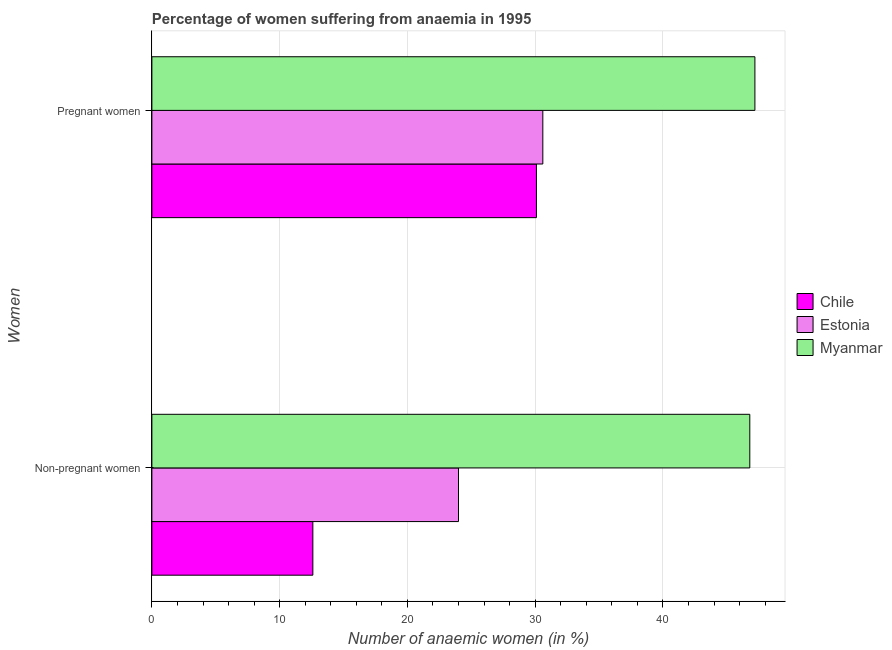How many different coloured bars are there?
Ensure brevity in your answer.  3. Are the number of bars on each tick of the Y-axis equal?
Your response must be concise. Yes. How many bars are there on the 1st tick from the bottom?
Offer a terse response. 3. What is the label of the 2nd group of bars from the top?
Make the answer very short. Non-pregnant women. Across all countries, what is the maximum percentage of non-pregnant anaemic women?
Your answer should be very brief. 46.8. Across all countries, what is the minimum percentage of pregnant anaemic women?
Give a very brief answer. 30.1. In which country was the percentage of non-pregnant anaemic women maximum?
Your answer should be compact. Myanmar. What is the total percentage of non-pregnant anaemic women in the graph?
Provide a succinct answer. 83.4. What is the difference between the percentage of non-pregnant anaemic women in Chile and that in Myanmar?
Offer a very short reply. -34.2. What is the difference between the percentage of non-pregnant anaemic women in Estonia and the percentage of pregnant anaemic women in Myanmar?
Your answer should be compact. -23.2. What is the average percentage of pregnant anaemic women per country?
Offer a very short reply. 35.97. What is the difference between the percentage of pregnant anaemic women and percentage of non-pregnant anaemic women in Estonia?
Your answer should be compact. 6.6. In how many countries, is the percentage of non-pregnant anaemic women greater than 8 %?
Make the answer very short. 3. What is the ratio of the percentage of pregnant anaemic women in Myanmar to that in Estonia?
Offer a very short reply. 1.54. In how many countries, is the percentage of pregnant anaemic women greater than the average percentage of pregnant anaemic women taken over all countries?
Offer a very short reply. 1. What does the 2nd bar from the top in Non-pregnant women represents?
Your answer should be very brief. Estonia. What does the 2nd bar from the bottom in Pregnant women represents?
Give a very brief answer. Estonia. How many bars are there?
Your response must be concise. 6. How many countries are there in the graph?
Provide a short and direct response. 3. Where does the legend appear in the graph?
Offer a very short reply. Center right. What is the title of the graph?
Offer a very short reply. Percentage of women suffering from anaemia in 1995. Does "Costa Rica" appear as one of the legend labels in the graph?
Your response must be concise. No. What is the label or title of the X-axis?
Offer a very short reply. Number of anaemic women (in %). What is the label or title of the Y-axis?
Provide a short and direct response. Women. What is the Number of anaemic women (in %) in Myanmar in Non-pregnant women?
Your response must be concise. 46.8. What is the Number of anaemic women (in %) of Chile in Pregnant women?
Make the answer very short. 30.1. What is the Number of anaemic women (in %) in Estonia in Pregnant women?
Your answer should be compact. 30.6. What is the Number of anaemic women (in %) in Myanmar in Pregnant women?
Make the answer very short. 47.2. Across all Women, what is the maximum Number of anaemic women (in %) of Chile?
Provide a succinct answer. 30.1. Across all Women, what is the maximum Number of anaemic women (in %) of Estonia?
Your answer should be compact. 30.6. Across all Women, what is the maximum Number of anaemic women (in %) of Myanmar?
Offer a terse response. 47.2. Across all Women, what is the minimum Number of anaemic women (in %) in Estonia?
Offer a terse response. 24. Across all Women, what is the minimum Number of anaemic women (in %) in Myanmar?
Keep it short and to the point. 46.8. What is the total Number of anaemic women (in %) in Chile in the graph?
Ensure brevity in your answer.  42.7. What is the total Number of anaemic women (in %) in Estonia in the graph?
Make the answer very short. 54.6. What is the total Number of anaemic women (in %) in Myanmar in the graph?
Keep it short and to the point. 94. What is the difference between the Number of anaemic women (in %) of Chile in Non-pregnant women and that in Pregnant women?
Your response must be concise. -17.5. What is the difference between the Number of anaemic women (in %) of Myanmar in Non-pregnant women and that in Pregnant women?
Your answer should be compact. -0.4. What is the difference between the Number of anaemic women (in %) of Chile in Non-pregnant women and the Number of anaemic women (in %) of Estonia in Pregnant women?
Offer a terse response. -18. What is the difference between the Number of anaemic women (in %) of Chile in Non-pregnant women and the Number of anaemic women (in %) of Myanmar in Pregnant women?
Ensure brevity in your answer.  -34.6. What is the difference between the Number of anaemic women (in %) of Estonia in Non-pregnant women and the Number of anaemic women (in %) of Myanmar in Pregnant women?
Make the answer very short. -23.2. What is the average Number of anaemic women (in %) of Chile per Women?
Offer a terse response. 21.35. What is the average Number of anaemic women (in %) in Estonia per Women?
Provide a succinct answer. 27.3. What is the difference between the Number of anaemic women (in %) of Chile and Number of anaemic women (in %) of Estonia in Non-pregnant women?
Your answer should be compact. -11.4. What is the difference between the Number of anaemic women (in %) in Chile and Number of anaemic women (in %) in Myanmar in Non-pregnant women?
Provide a short and direct response. -34.2. What is the difference between the Number of anaemic women (in %) in Estonia and Number of anaemic women (in %) in Myanmar in Non-pregnant women?
Ensure brevity in your answer.  -22.8. What is the difference between the Number of anaemic women (in %) in Chile and Number of anaemic women (in %) in Estonia in Pregnant women?
Provide a short and direct response. -0.5. What is the difference between the Number of anaemic women (in %) in Chile and Number of anaemic women (in %) in Myanmar in Pregnant women?
Provide a short and direct response. -17.1. What is the difference between the Number of anaemic women (in %) of Estonia and Number of anaemic women (in %) of Myanmar in Pregnant women?
Keep it short and to the point. -16.6. What is the ratio of the Number of anaemic women (in %) in Chile in Non-pregnant women to that in Pregnant women?
Provide a short and direct response. 0.42. What is the ratio of the Number of anaemic women (in %) in Estonia in Non-pregnant women to that in Pregnant women?
Make the answer very short. 0.78. What is the ratio of the Number of anaemic women (in %) in Myanmar in Non-pregnant women to that in Pregnant women?
Offer a very short reply. 0.99. What is the difference between the highest and the second highest Number of anaemic women (in %) of Estonia?
Your answer should be very brief. 6.6. What is the difference between the highest and the lowest Number of anaemic women (in %) of Chile?
Offer a terse response. 17.5. 